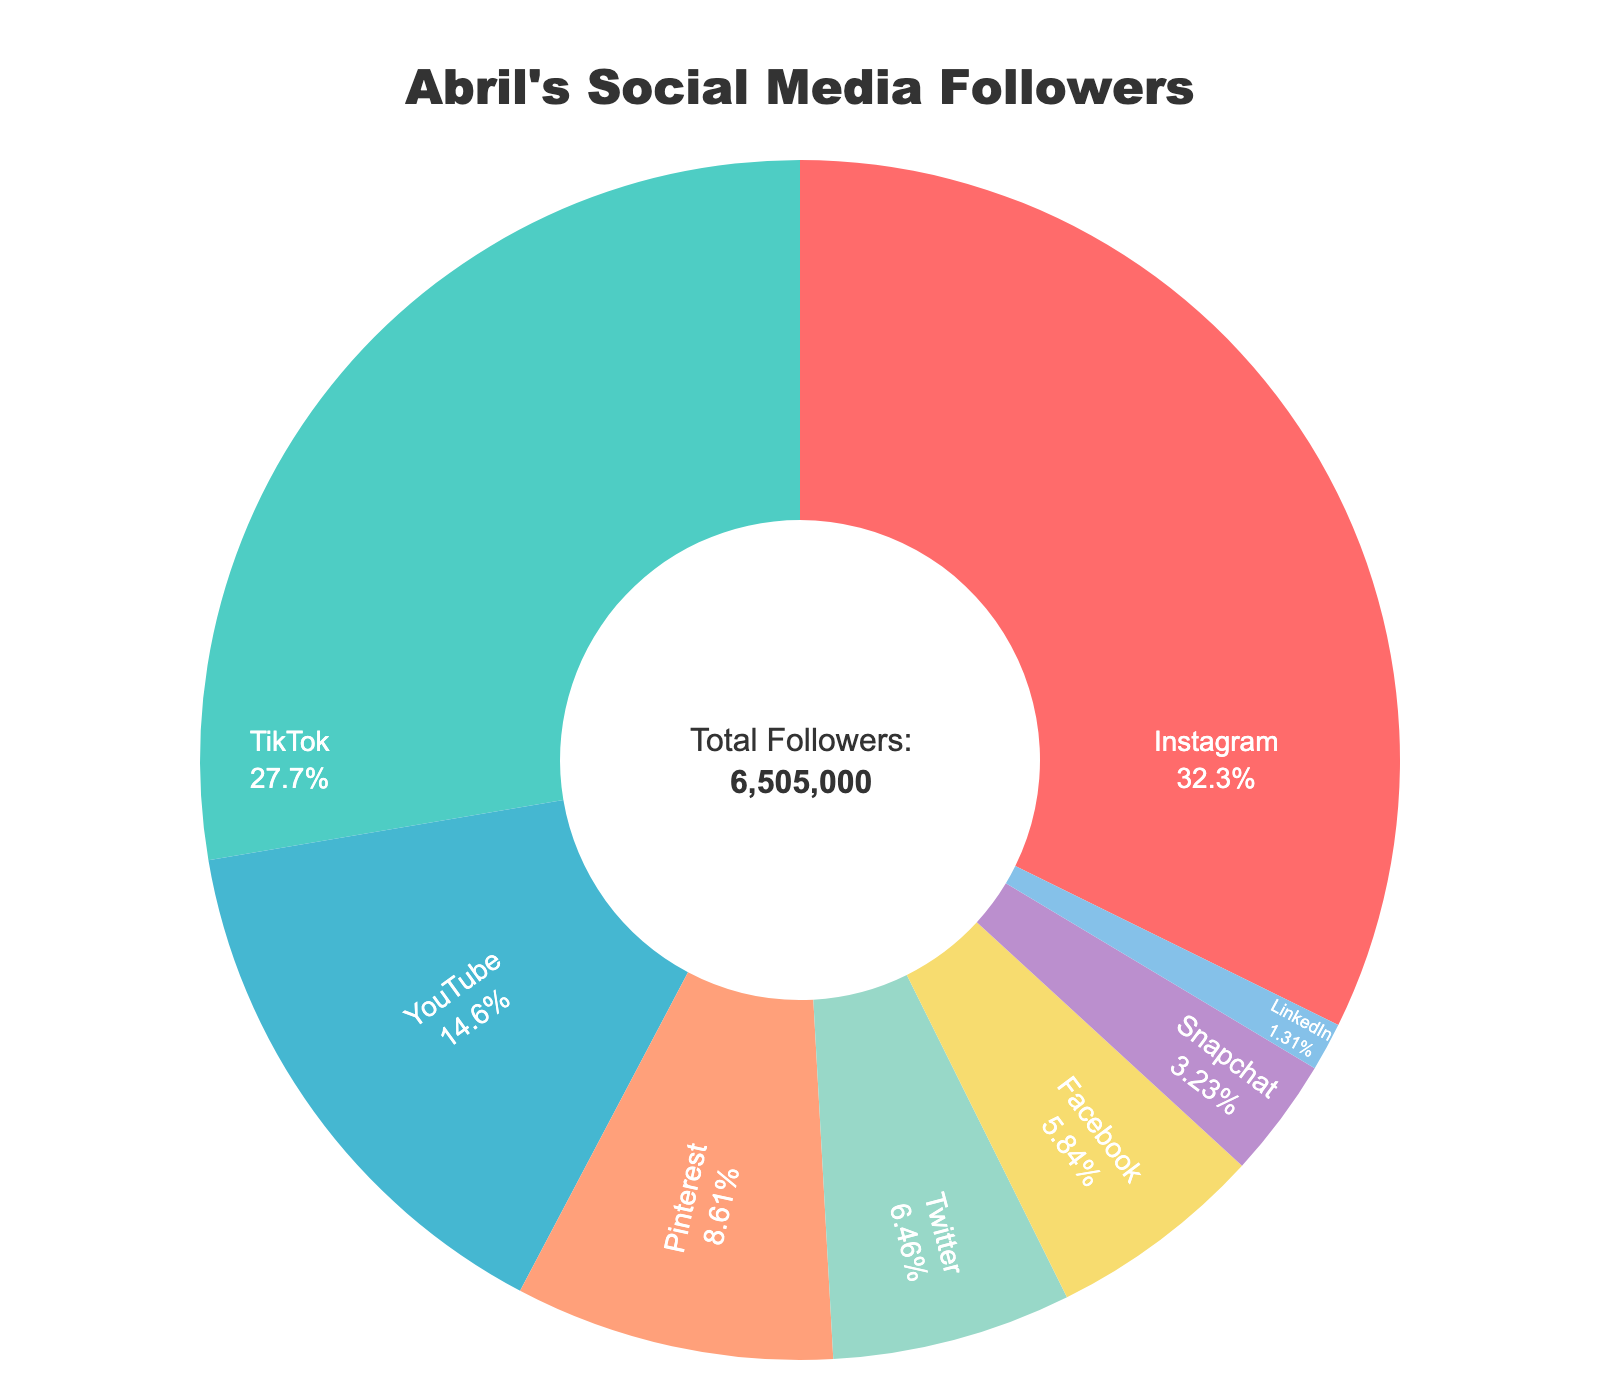Which platform has the highest number of followers? The chart shows various sections for each platform with their follower counts. The largest section corresponds to Instagram, indicating the highest number of followers.
Answer: Instagram How many more followers does Instagram have compared to Twitter? First, identify the follower counts for both platforms: Instagram with 2,100,000 followers and Twitter with 420,000 followers. Subtract Twitter's count from Instagram's: 2,100,000 - 420,000 = 1,680,000.
Answer: 1,680,000 Which platforms have less than one million followers? Look at the chart sections with follower counts below 1 million. These platforms are Pinterest (560,000), Twitter (420,000), Facebook (380,000), Snapchat (210,000), and LinkedIn (85,000).
Answer: Pinterest, Twitter, Facebook, Snapchat, LinkedIn What is the total number of followers on TikTok and YouTube combined? The chart indicates TikTok has 1,800,000 followers and YouTube has 950,000 followers. Add these numbers: 1,800,000 + 950,000 = 2,750,000.
Answer: 2,750,000 By how much does TikTok's follower count exceed Pinterest’s? TikTok has 1,800,000 followers, and Pinterest has 560,000 followers. Subtract Pinterest's count from TikTok's: 1,800,000 - 560,000 = 1,240,000.
Answer: 1,240,000 What percentage of Abril's total followers are on Instagram? The chart indicates Instagram has 2,100,000 followers. The annotation under the chart gives the total number of followers: 6,645,000. Calculate the percentage: (2,100,000 / 6,645,000) * 100 ≈ 31.6%.
Answer: 31.6% Which platform has the smallest follower count, and what is it? The smallest section on the chart represents LinkedIn, with 85,000 followers.
Answer: LinkedIn, 85,000 Are there more followers on YouTube or Facebook? Compare the follower counts: YouTube has 950,000 followers and Facebook has 380,000 followers. YouTube has more followers.
Answer: YouTube What is the combined number of followers on Twitter, Facebook, and Snapchat? Sum the follower counts for these platforms: Twitter (420,000), Facebook (380,000), and Snapchat (210,000). 420,000 + 380,000 + 210,000 = 1,010,000.
Answer: 1,010,000 